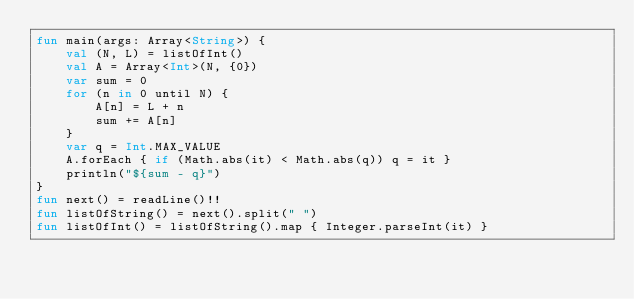<code> <loc_0><loc_0><loc_500><loc_500><_Kotlin_>fun main(args: Array<String>) {
    val (N, L) = listOfInt()
    val A = Array<Int>(N, {0})
    var sum = 0
    for (n in 0 until N) {
        A[n] = L + n
        sum += A[n]
    }
    var q = Int.MAX_VALUE
    A.forEach { if (Math.abs(it) < Math.abs(q)) q = it }
    println("${sum - q}")
}
fun next() = readLine()!!
fun listOfString() = next().split(" ")
fun listOfInt() = listOfString().map { Integer.parseInt(it) }
</code> 